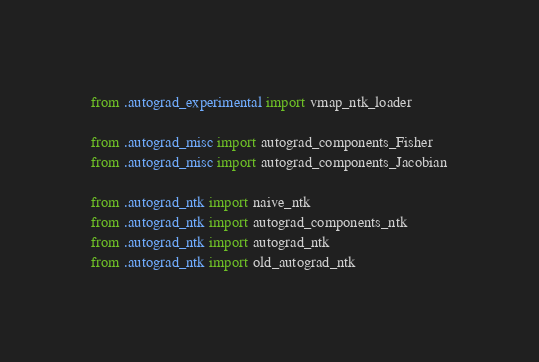<code> <loc_0><loc_0><loc_500><loc_500><_Python_>from .autograd_experimental import vmap_ntk_loader

from .autograd_misc import autograd_components_Fisher
from .autograd_misc import autograd_components_Jacobian

from .autograd_ntk import naive_ntk
from .autograd_ntk import autograd_components_ntk
from .autograd_ntk import autograd_ntk
from .autograd_ntk import old_autograd_ntk

</code> 